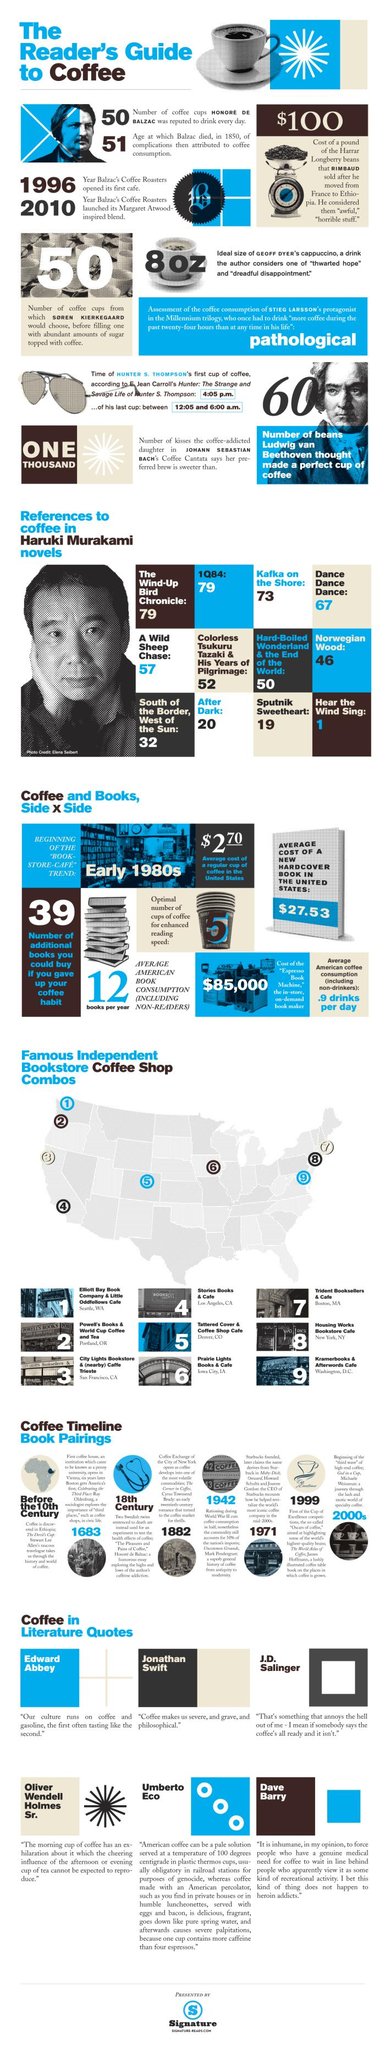Highlight a few significant elements in this photo. The name of the bookstore coffee shop located in Los Angeles is Stories Books & Cafe. In Haruki Murakami's novel "Hear The Wind Sing," there is only a single mention of the famous drink "Coffee. Sputnik Sweetheart contains 19 pieces of evidence related to the famous drink coffee. In the novel "Kafka on the Shore," the word "coffee" is written 73 times. In the work in question, there are 67 pieces of evidence related to the famous drink "Coffee." Dance Dance Dance... 